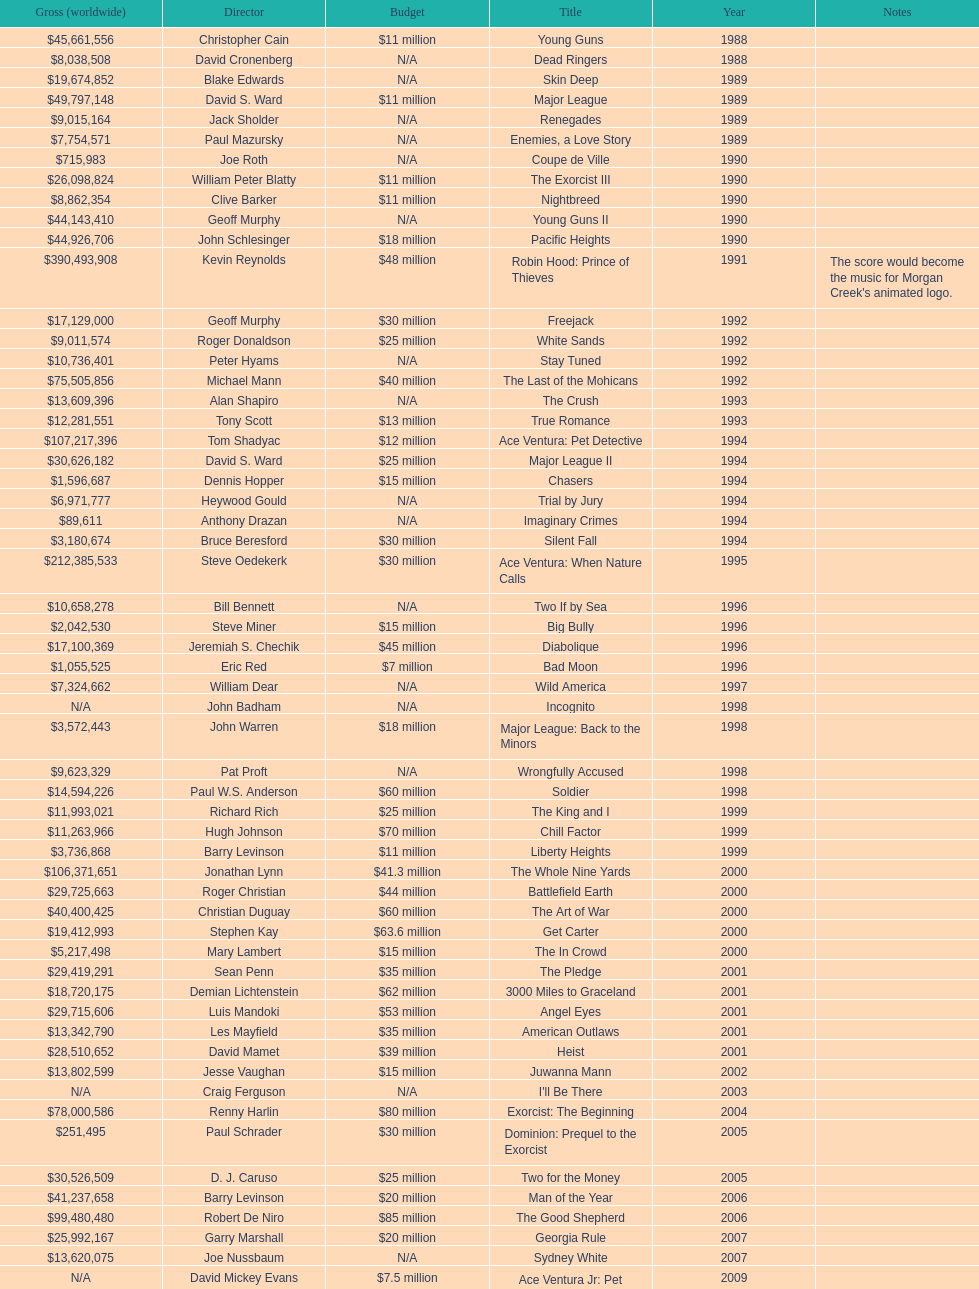How many films did morgan creek make in 2006? 2. I'm looking to parse the entire table for insights. Could you assist me with that? {'header': ['Gross (worldwide)', 'Director', 'Budget', 'Title', 'Year', 'Notes'], 'rows': [['$45,661,556', 'Christopher Cain', '$11 million', 'Young Guns', '1988', ''], ['$8,038,508', 'David Cronenberg', 'N/A', 'Dead Ringers', '1988', ''], ['$19,674,852', 'Blake Edwards', 'N/A', 'Skin Deep', '1989', ''], ['$49,797,148', 'David S. Ward', '$11 million', 'Major League', '1989', ''], ['$9,015,164', 'Jack Sholder', 'N/A', 'Renegades', '1989', ''], ['$7,754,571', 'Paul Mazursky', 'N/A', 'Enemies, a Love Story', '1989', ''], ['$715,983', 'Joe Roth', 'N/A', 'Coupe de Ville', '1990', ''], ['$26,098,824', 'William Peter Blatty', '$11 million', 'The Exorcist III', '1990', ''], ['$8,862,354', 'Clive Barker', '$11 million', 'Nightbreed', '1990', ''], ['$44,143,410', 'Geoff Murphy', 'N/A', 'Young Guns II', '1990', ''], ['$44,926,706', 'John Schlesinger', '$18 million', 'Pacific Heights', '1990', ''], ['$390,493,908', 'Kevin Reynolds', '$48 million', 'Robin Hood: Prince of Thieves', '1991', "The score would become the music for Morgan Creek's animated logo."], ['$17,129,000', 'Geoff Murphy', '$30 million', 'Freejack', '1992', ''], ['$9,011,574', 'Roger Donaldson', '$25 million', 'White Sands', '1992', ''], ['$10,736,401', 'Peter Hyams', 'N/A', 'Stay Tuned', '1992', ''], ['$75,505,856', 'Michael Mann', '$40 million', 'The Last of the Mohicans', '1992', ''], ['$13,609,396', 'Alan Shapiro', 'N/A', 'The Crush', '1993', ''], ['$12,281,551', 'Tony Scott', '$13 million', 'True Romance', '1993', ''], ['$107,217,396', 'Tom Shadyac', '$12 million', 'Ace Ventura: Pet Detective', '1994', ''], ['$30,626,182', 'David S. Ward', '$25 million', 'Major League II', '1994', ''], ['$1,596,687', 'Dennis Hopper', '$15 million', 'Chasers', '1994', ''], ['$6,971,777', 'Heywood Gould', 'N/A', 'Trial by Jury', '1994', ''], ['$89,611', 'Anthony Drazan', 'N/A', 'Imaginary Crimes', '1994', ''], ['$3,180,674', 'Bruce Beresford', '$30 million', 'Silent Fall', '1994', ''], ['$212,385,533', 'Steve Oedekerk', '$30 million', 'Ace Ventura: When Nature Calls', '1995', ''], ['$10,658,278', 'Bill Bennett', 'N/A', 'Two If by Sea', '1996', ''], ['$2,042,530', 'Steve Miner', '$15 million', 'Big Bully', '1996', ''], ['$17,100,369', 'Jeremiah S. Chechik', '$45 million', 'Diabolique', '1996', ''], ['$1,055,525', 'Eric Red', '$7 million', 'Bad Moon', '1996', ''], ['$7,324,662', 'William Dear', 'N/A', 'Wild America', '1997', ''], ['N/A', 'John Badham', 'N/A', 'Incognito', '1998', ''], ['$3,572,443', 'John Warren', '$18 million', 'Major League: Back to the Minors', '1998', ''], ['$9,623,329', 'Pat Proft', 'N/A', 'Wrongfully Accused', '1998', ''], ['$14,594,226', 'Paul W.S. Anderson', '$60 million', 'Soldier', '1998', ''], ['$11,993,021', 'Richard Rich', '$25 million', 'The King and I', '1999', ''], ['$11,263,966', 'Hugh Johnson', '$70 million', 'Chill Factor', '1999', ''], ['$3,736,868', 'Barry Levinson', '$11 million', 'Liberty Heights', '1999', ''], ['$106,371,651', 'Jonathan Lynn', '$41.3 million', 'The Whole Nine Yards', '2000', ''], ['$29,725,663', 'Roger Christian', '$44 million', 'Battlefield Earth', '2000', ''], ['$40,400,425', 'Christian Duguay', '$60 million', 'The Art of War', '2000', ''], ['$19,412,993', 'Stephen Kay', '$63.6 million', 'Get Carter', '2000', ''], ['$5,217,498', 'Mary Lambert', '$15 million', 'The In Crowd', '2000', ''], ['$29,419,291', 'Sean Penn', '$35 million', 'The Pledge', '2001', ''], ['$18,720,175', 'Demian Lichtenstein', '$62 million', '3000 Miles to Graceland', '2001', ''], ['$29,715,606', 'Luis Mandoki', '$53 million', 'Angel Eyes', '2001', ''], ['$13,342,790', 'Les Mayfield', '$35 million', 'American Outlaws', '2001', ''], ['$28,510,652', 'David Mamet', '$39 million', 'Heist', '2001', ''], ['$13,802,599', 'Jesse Vaughan', '$15 million', 'Juwanna Mann', '2002', ''], ['N/A', 'Craig Ferguson', 'N/A', "I'll Be There", '2003', ''], ['$78,000,586', 'Renny Harlin', '$80 million', 'Exorcist: The Beginning', '2004', ''], ['$251,495', 'Paul Schrader', '$30 million', 'Dominion: Prequel to the Exorcist', '2005', ''], ['$30,526,509', 'D. J. Caruso', '$25 million', 'Two for the Money', '2005', ''], ['$41,237,658', 'Barry Levinson', '$20 million', 'Man of the Year', '2006', ''], ['$99,480,480', 'Robert De Niro', '$85 million', 'The Good Shepherd', '2006', ''], ['$25,992,167', 'Garry Marshall', '$20 million', 'Georgia Rule', '2007', ''], ['$13,620,075', 'Joe Nussbaum', 'N/A', 'Sydney White', '2007', ''], ['N/A', 'David Mickey Evans', '$7.5 million', 'Ace Ventura Jr: Pet Detective', '2009', ''], ['$38,502,340', 'Jim Sheridan', '$50 million', 'Dream House', '2011', ''], ['$27,428,670', 'Matthijs van Heijningen Jr.', '$38 million', 'The Thing', '2011', ''], ['', 'Antoine Fuqua', '$45 million', 'Tupac', '2014', '']]} 